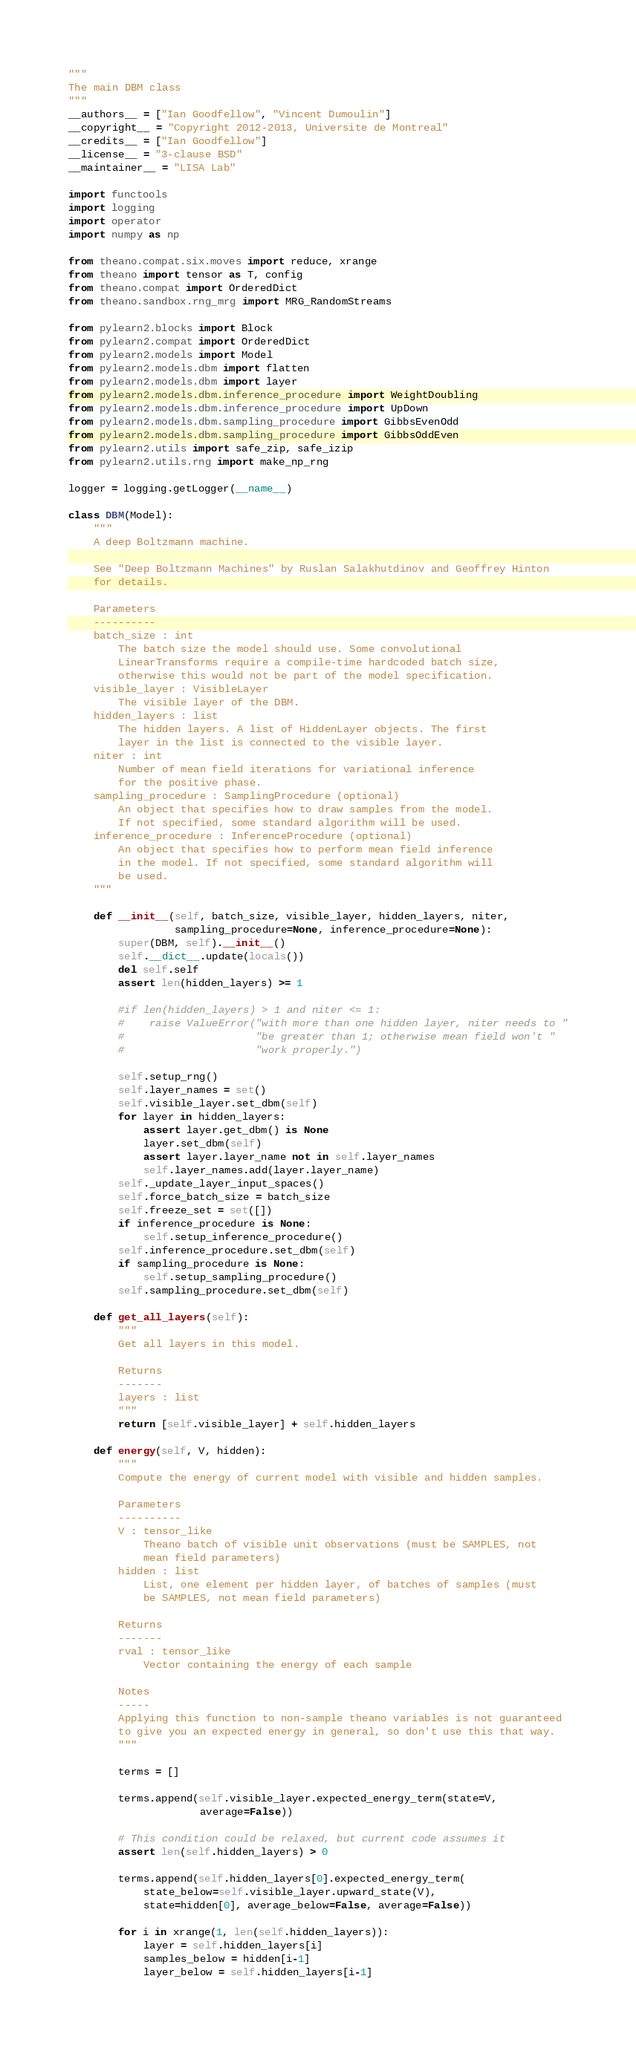<code> <loc_0><loc_0><loc_500><loc_500><_Python_>"""
The main DBM class
"""
__authors__ = ["Ian Goodfellow", "Vincent Dumoulin"]
__copyright__ = "Copyright 2012-2013, Universite de Montreal"
__credits__ = ["Ian Goodfellow"]
__license__ = "3-clause BSD"
__maintainer__ = "LISA Lab"

import functools
import logging
import operator
import numpy as np

from theano.compat.six.moves import reduce, xrange
from theano import tensor as T, config
from theano.compat import OrderedDict
from theano.sandbox.rng_mrg import MRG_RandomStreams

from pylearn2.blocks import Block
from pylearn2.compat import OrderedDict
from pylearn2.models import Model
from pylearn2.models.dbm import flatten
from pylearn2.models.dbm import layer
from pylearn2.models.dbm.inference_procedure import WeightDoubling
from pylearn2.models.dbm.inference_procedure import UpDown
from pylearn2.models.dbm.sampling_procedure import GibbsEvenOdd
from pylearn2.models.dbm.sampling_procedure import GibbsOddEven
from pylearn2.utils import safe_zip, safe_izip
from pylearn2.utils.rng import make_np_rng

logger = logging.getLogger(__name__)

class DBM(Model):
    """
    A deep Boltzmann machine.

    See "Deep Boltzmann Machines" by Ruslan Salakhutdinov and Geoffrey Hinton
    for details.

    Parameters
    ----------
    batch_size : int
        The batch size the model should use. Some convolutional
        LinearTransforms require a compile-time hardcoded batch size,
        otherwise this would not be part of the model specification.
    visible_layer : VisibleLayer
        The visible layer of the DBM.
    hidden_layers : list
        The hidden layers. A list of HiddenLayer objects. The first
        layer in the list is connected to the visible layer.
    niter : int
        Number of mean field iterations for variational inference
        for the positive phase.
    sampling_procedure : SamplingProcedure (optional)
        An object that specifies how to draw samples from the model.
        If not specified, some standard algorithm will be used.
    inference_procedure : InferenceProcedure (optional)
        An object that specifies how to perform mean field inference
        in the model. If not specified, some standard algorithm will
        be used.
    """

    def __init__(self, batch_size, visible_layer, hidden_layers, niter,
                 sampling_procedure=None, inference_procedure=None):
        super(DBM, self).__init__()
        self.__dict__.update(locals())
        del self.self
        assert len(hidden_layers) >= 1

        #if len(hidden_layers) > 1 and niter <= 1:
        #    raise ValueError("with more than one hidden layer, niter needs to "
        #                     "be greater than 1; otherwise mean field won't "
        #                     "work properly.")

        self.setup_rng()
        self.layer_names = set()
        self.visible_layer.set_dbm(self)
        for layer in hidden_layers:
            assert layer.get_dbm() is None
            layer.set_dbm(self)
            assert layer.layer_name not in self.layer_names
            self.layer_names.add(layer.layer_name)
        self._update_layer_input_spaces()
        self.force_batch_size = batch_size
        self.freeze_set = set([])
        if inference_procedure is None:
            self.setup_inference_procedure()
        self.inference_procedure.set_dbm(self)
        if sampling_procedure is None:
            self.setup_sampling_procedure()
        self.sampling_procedure.set_dbm(self)

    def get_all_layers(self):
        """
        Get all layers in this model.

        Returns
        -------
        layers : list
        """
        return [self.visible_layer] + self.hidden_layers

    def energy(self, V, hidden):
        """
        Compute the energy of current model with visible and hidden samples.

        Parameters
        ----------
        V : tensor_like
            Theano batch of visible unit observations (must be SAMPLES, not
            mean field parameters)
        hidden : list
            List, one element per hidden layer, of batches of samples (must
            be SAMPLES, not mean field parameters)

        Returns
        -------
        rval : tensor_like
            Vector containing the energy of each sample

        Notes
        -----
        Applying this function to non-sample theano variables is not guaranteed
        to give you an expected energy in general, so don't use this that way.
        """

        terms = []

        terms.append(self.visible_layer.expected_energy_term(state=V,
                     average=False))

        # This condition could be relaxed, but current code assumes it
        assert len(self.hidden_layers) > 0

        terms.append(self.hidden_layers[0].expected_energy_term(
            state_below=self.visible_layer.upward_state(V),
            state=hidden[0], average_below=False, average=False))

        for i in xrange(1, len(self.hidden_layers)):
            layer = self.hidden_layers[i]
            samples_below = hidden[i-1]
            layer_below = self.hidden_layers[i-1]</code> 